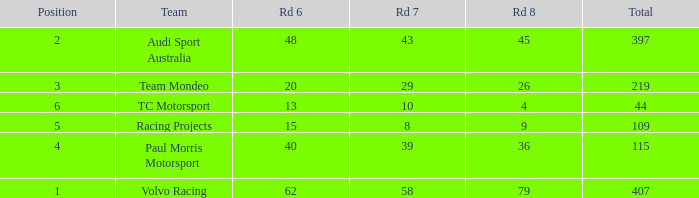What is the sum of total values for Rd 7 less than 8? None. 